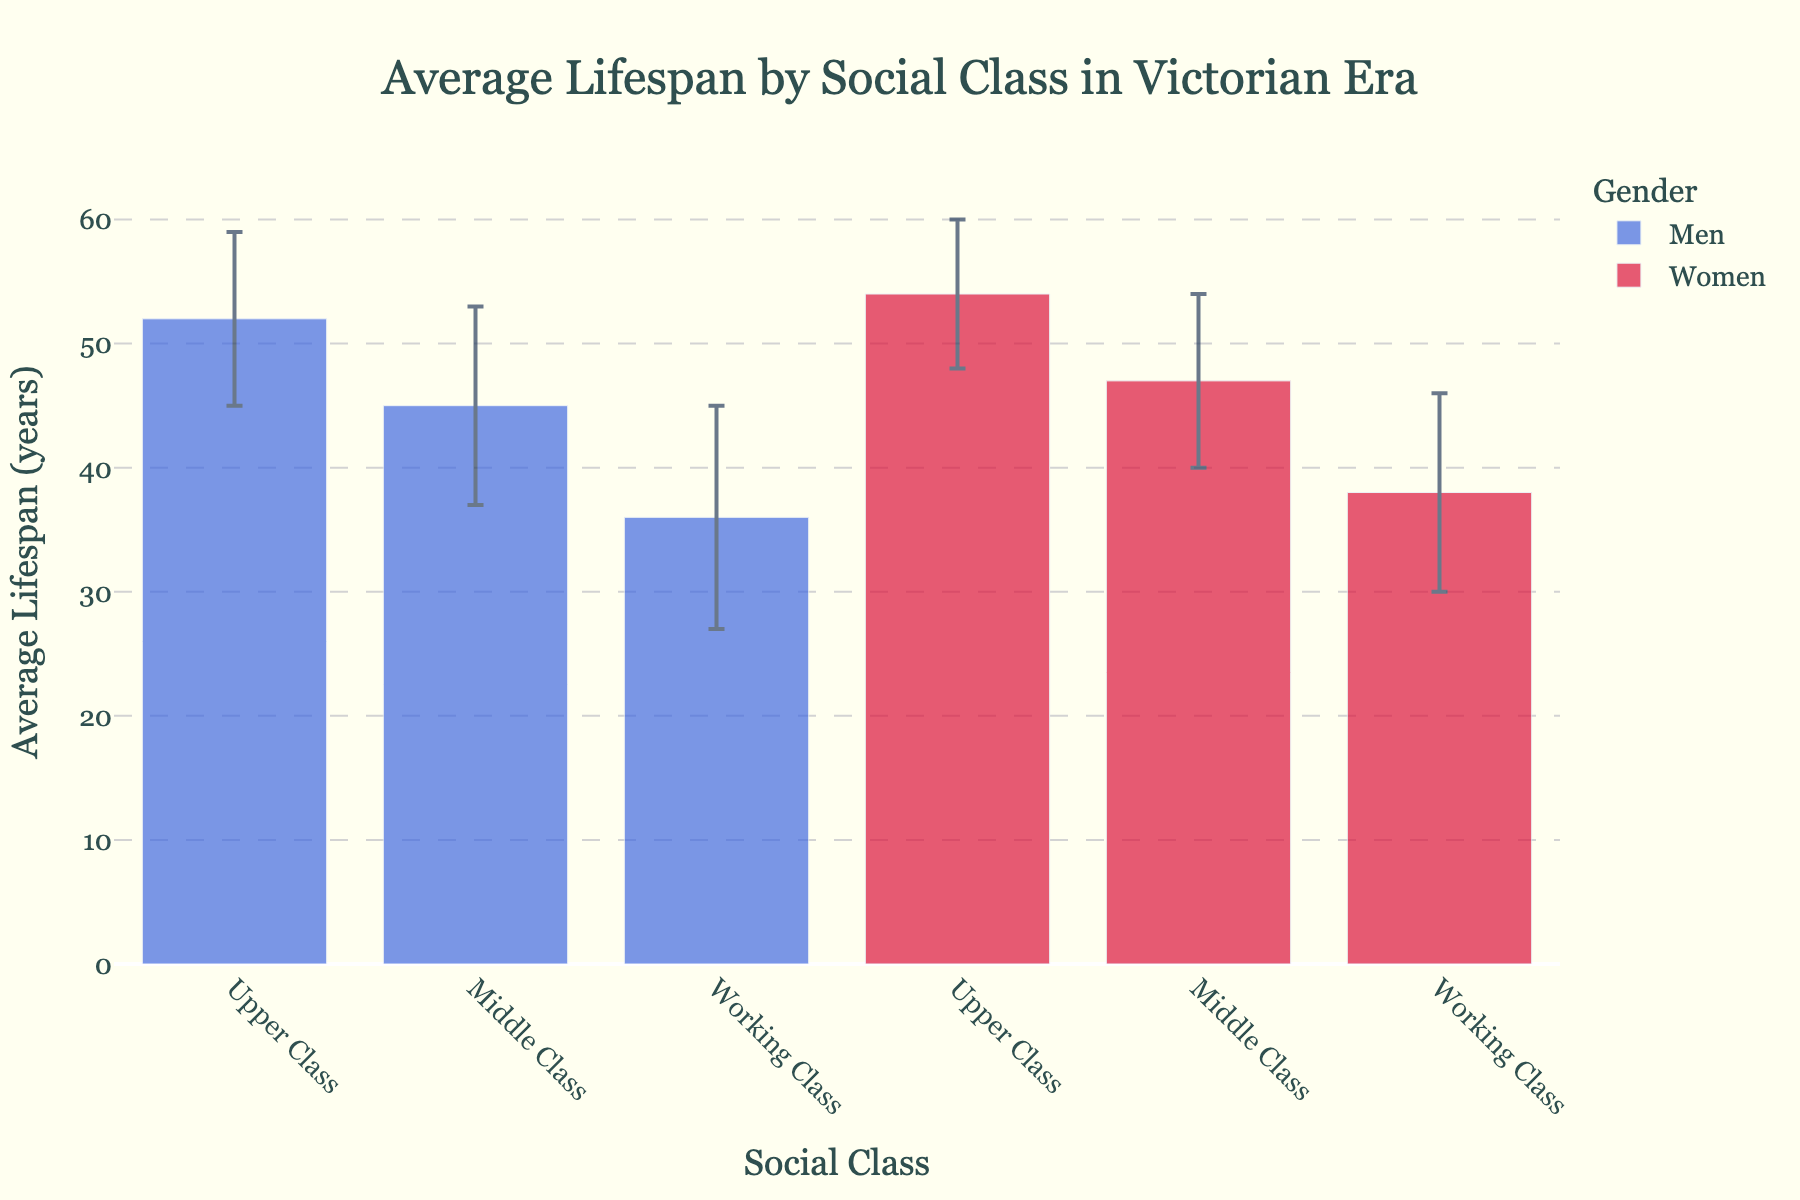What's the title of the figure? The title of the figure is shown at the top center and reads 'Average Lifespan by Social Class in Victorian Era'.
Answer: 'Average Lifespan by Social Class in Victorian Era' What is the average lifespan of Upper Class Men? The average lifespan of Upper Class Men is labeled directly on the y-axis scale for the corresponding bar. It shows 52 years.
Answer: 52 years Which social class has the shortest lifespan for both men and women? By examining the y-axis values, the bars representing lifespans for Working Class Men and Working Class Women are the shortest.
Answer: Working Class What is the difference in average lifespan between Middle Class Men and Middle Class Women? The average lifespan for Middle Class Men is 45 years, and for Middle Class Women is 47 years. The difference is 47 - 45.
Answer: 2 years How many social classes are represented in the chart? The x-axis displays six categories, each corresponding to a different social class and gender combination. By counting these, there are six categories.
Answer: 6 Does any bar on the chart overlap with error bars from two different groups? By visually examining the chart, the error bars of the Working Class Men and Working Class Women do not overlap. However, Upper Class Men and Upper Class Women have closely aligned error bars.
Answer: No Which gender has a higher average lifespan within each social class? For Upper Class and Middle Class, women have a higher average lifespan than men. Similarly, in Working Class, women have a higher average lifespan. This can be seen from the heights of the respective bars.
Answer: Women What is the average of the average lifespans for all the presented groups? The given average lifespans are 52, 54, 45, 47, 36, 38. Summing them gives 272, and dividing by 6 gives the mean: 272/6.
Answer: 45.33 years Which group shows the highest standard deviation in lifespan? Standard deviations are provided: Upper Class Men (7), Upper Class Women (6), Middle Class Men (8), Middle Class Women (7), Working Class Men (9), Working Class Women (8). Working Class Men have the highest standard deviation (9 years).
Answer: Working Class Men How does the variability of lifespans compare between the genders within each class? Observing the error bars (standard deviations): Upper Class Men (7) and Women (6), Middle Class Men (8) and Women (7), Working Class Men (9) and Women (8). In each social class, men show slightly higher variability.
Answer: Men have higher variability in each class 